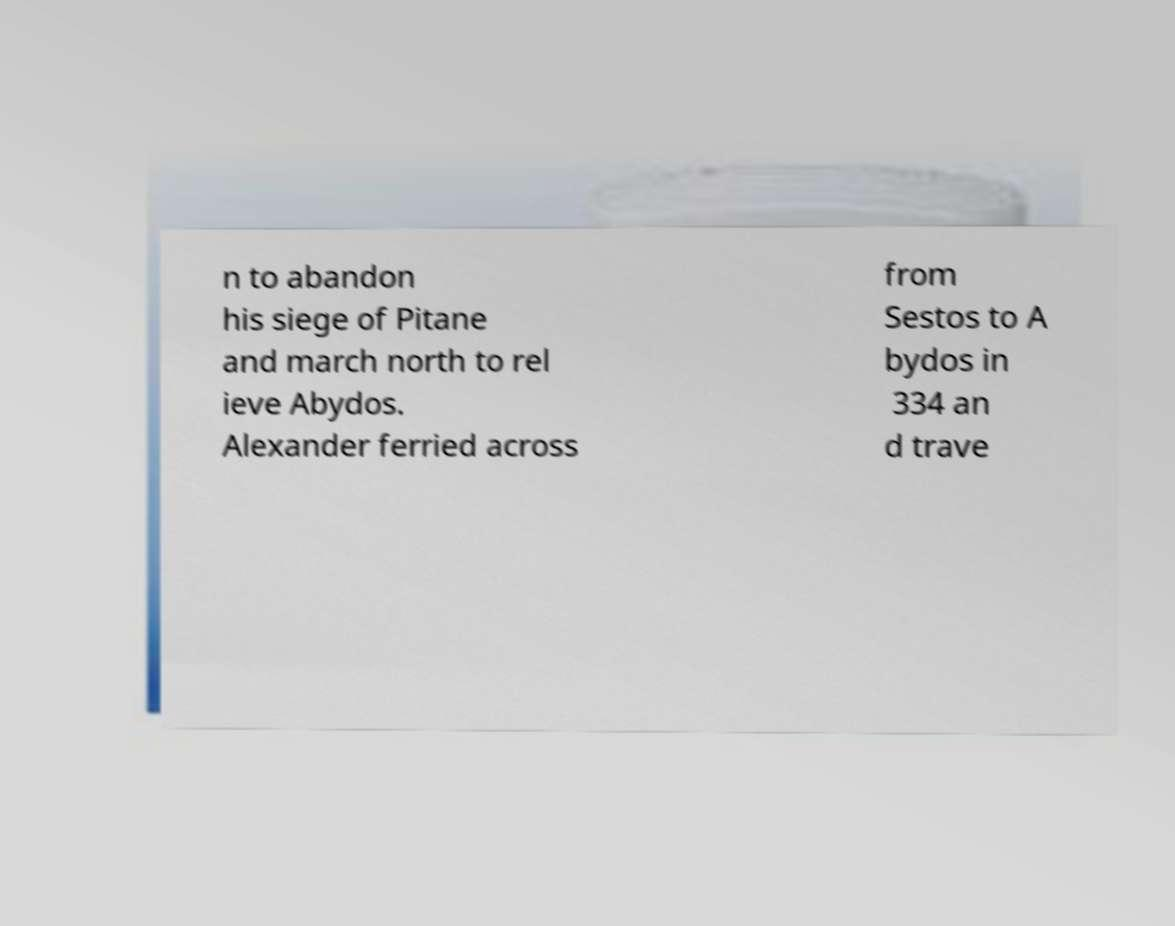Can you accurately transcribe the text from the provided image for me? n to abandon his siege of Pitane and march north to rel ieve Abydos. Alexander ferried across from Sestos to A bydos in 334 an d trave 